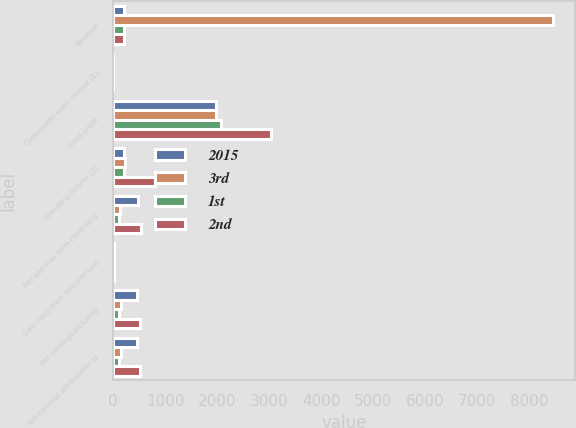Convert chart to OTSL. <chart><loc_0><loc_0><loc_500><loc_500><stacked_bar_chart><ecel><fcel>Revenue<fcel>Comparable sales change (1)<fcel>Gross profit<fcel>Operating income (2)<fcel>Net earnings from continuing<fcel>Gain (loss) from discontinued<fcel>Net earnings including<fcel>Net earnings attributable to<nl><fcel>2015<fcel>205<fcel>1.8<fcel>1967<fcel>210<fcel>469<fcel>8<fcel>461<fcel>461<nl><fcel>3rd<fcel>8459<fcel>2.2<fcel>1978<fcel>225<fcel>137<fcel>10<fcel>147<fcel>146<nl><fcel>1st<fcel>205<fcel>2.9<fcel>2076<fcel>205<fcel>116<fcel>9<fcel>107<fcel>107<nl><fcel>2nd<fcel>205<fcel>2<fcel>3026<fcel>810<fcel>524<fcel>4<fcel>520<fcel>519<nl></chart> 